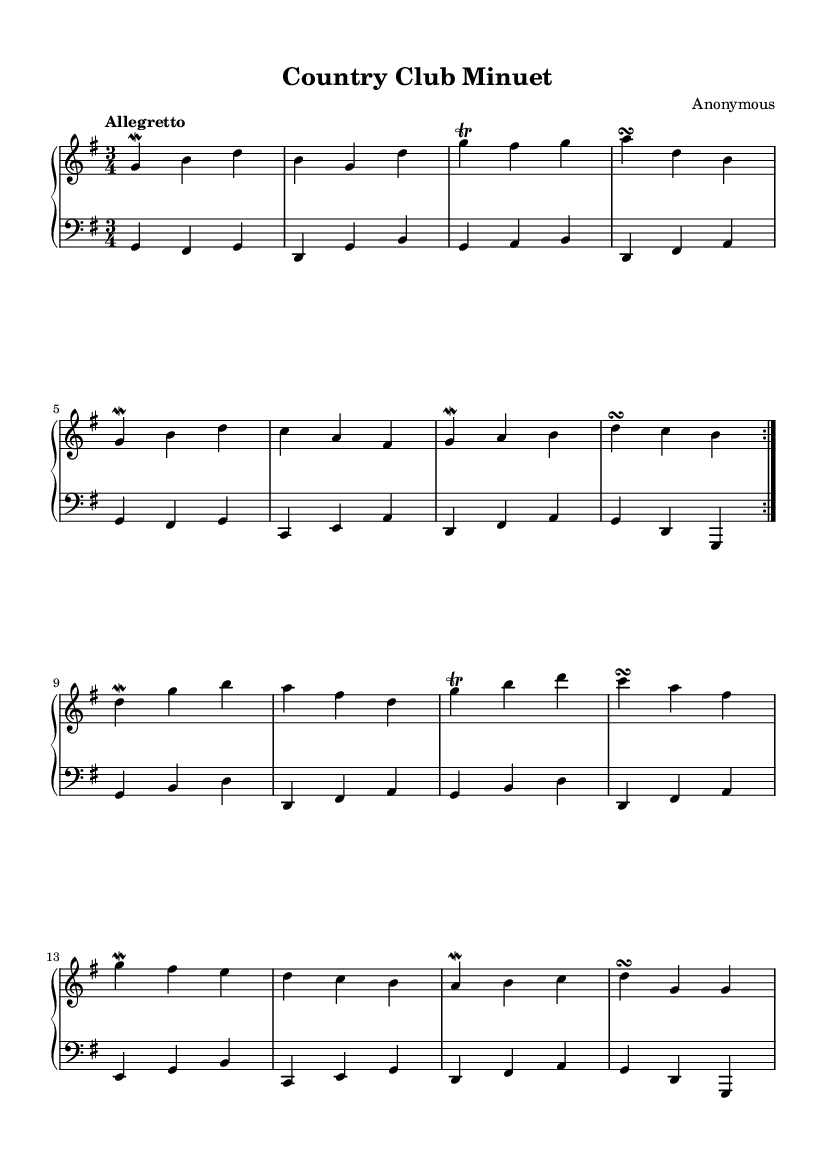What is the key signature of this music? The key signature shows one sharp at the beginning, indicating that the piece is in G major, which has the notes of G, A, B, C, D, E, and F#.
Answer: G major What is the time signature of the music? The time signature is located after the clef and indicates how many beats are in each measure. In this case, it shows 3/4, meaning there are three beats in every measure, with the quarter note receiving one beat.
Answer: 3/4 What is the tempo marking for this piece? The tempo marking is indicated at the beginning of the score as "Allegretto." This signifies a moderately fast tempo, typically between andante and allegro.
Answer: Allegretto How many times is the first section repeated? The repeated section is indicated by the "volta" markings in the score. The score has two "volta" markings, indicating that the first section is to be played twice.
Answer: 2 Which ornament is used on the note G in the upper voice? The sheet music shows specific symbols that indicate ornamental techniques. The note G has a "mordent" symbol next to it, indicating it should be played with this ornamentation.
Answer: Mordent How many measures are played in the lower voice during the first section? The first section in the lower voice contains eight measures, as counted by observing the individual groups of notes separated by bar lines throughout that section.
Answer: 8 What type of piece is this composed for? The score is labeled as a "PianoStaff," indicating that it is meant to be played on the keyboard, specifically for the piano, which captures the spirit of the harpsichord typical of the Baroque style.
Answer: Piano 